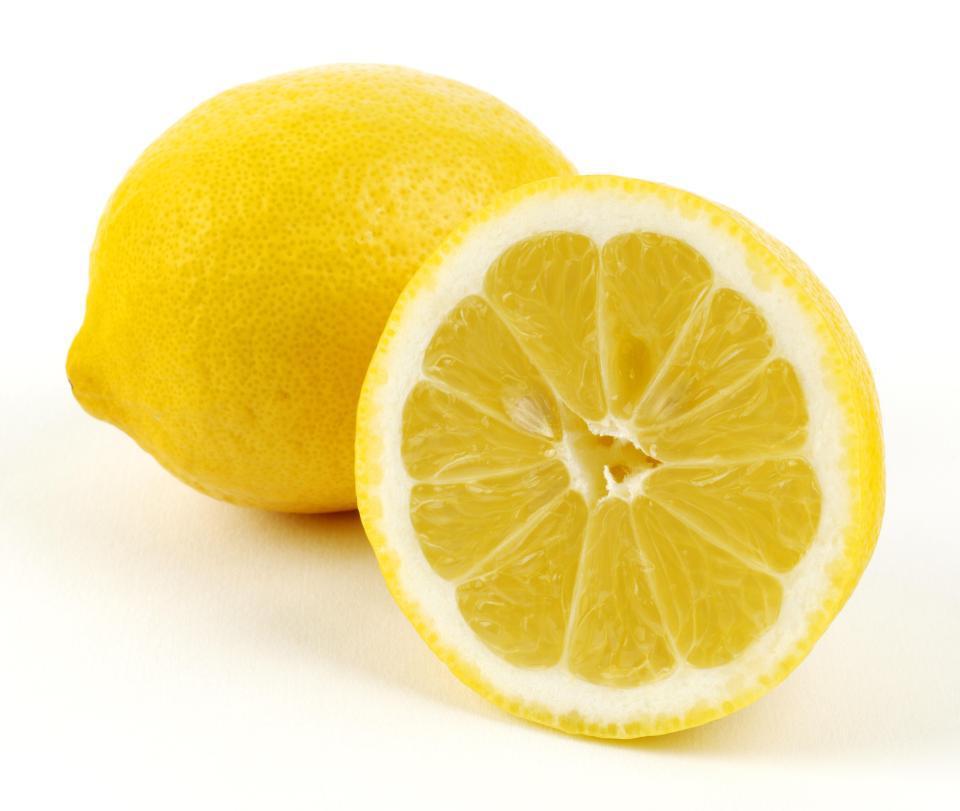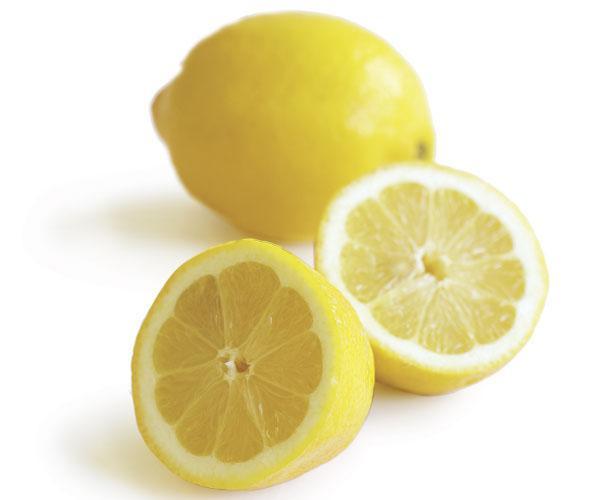The first image is the image on the left, the second image is the image on the right. Considering the images on both sides, is "There are two whole lemons and three lemon halves." valid? Answer yes or no. Yes. 